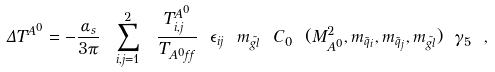<formula> <loc_0><loc_0><loc_500><loc_500>\Delta T ^ { A ^ { 0 } } = - \frac { \alpha _ { s } } { 3 \pi } \ \sum _ { i , j = 1 } ^ { 2 } \ \frac { T _ { i , j } ^ { A ^ { 0 } } } { T _ { A ^ { 0 } f f } } \ \epsilon _ { i j } \ m _ { \tilde { g l } } \ C _ { 0 } \ ( M _ { A ^ { 0 } } ^ { 2 } , m _ { \tilde { q } _ { i } } , m _ { \tilde { q } _ { j } } , m _ { \tilde { g l } } ) \ \gamma _ { 5 } \ ,</formula> 